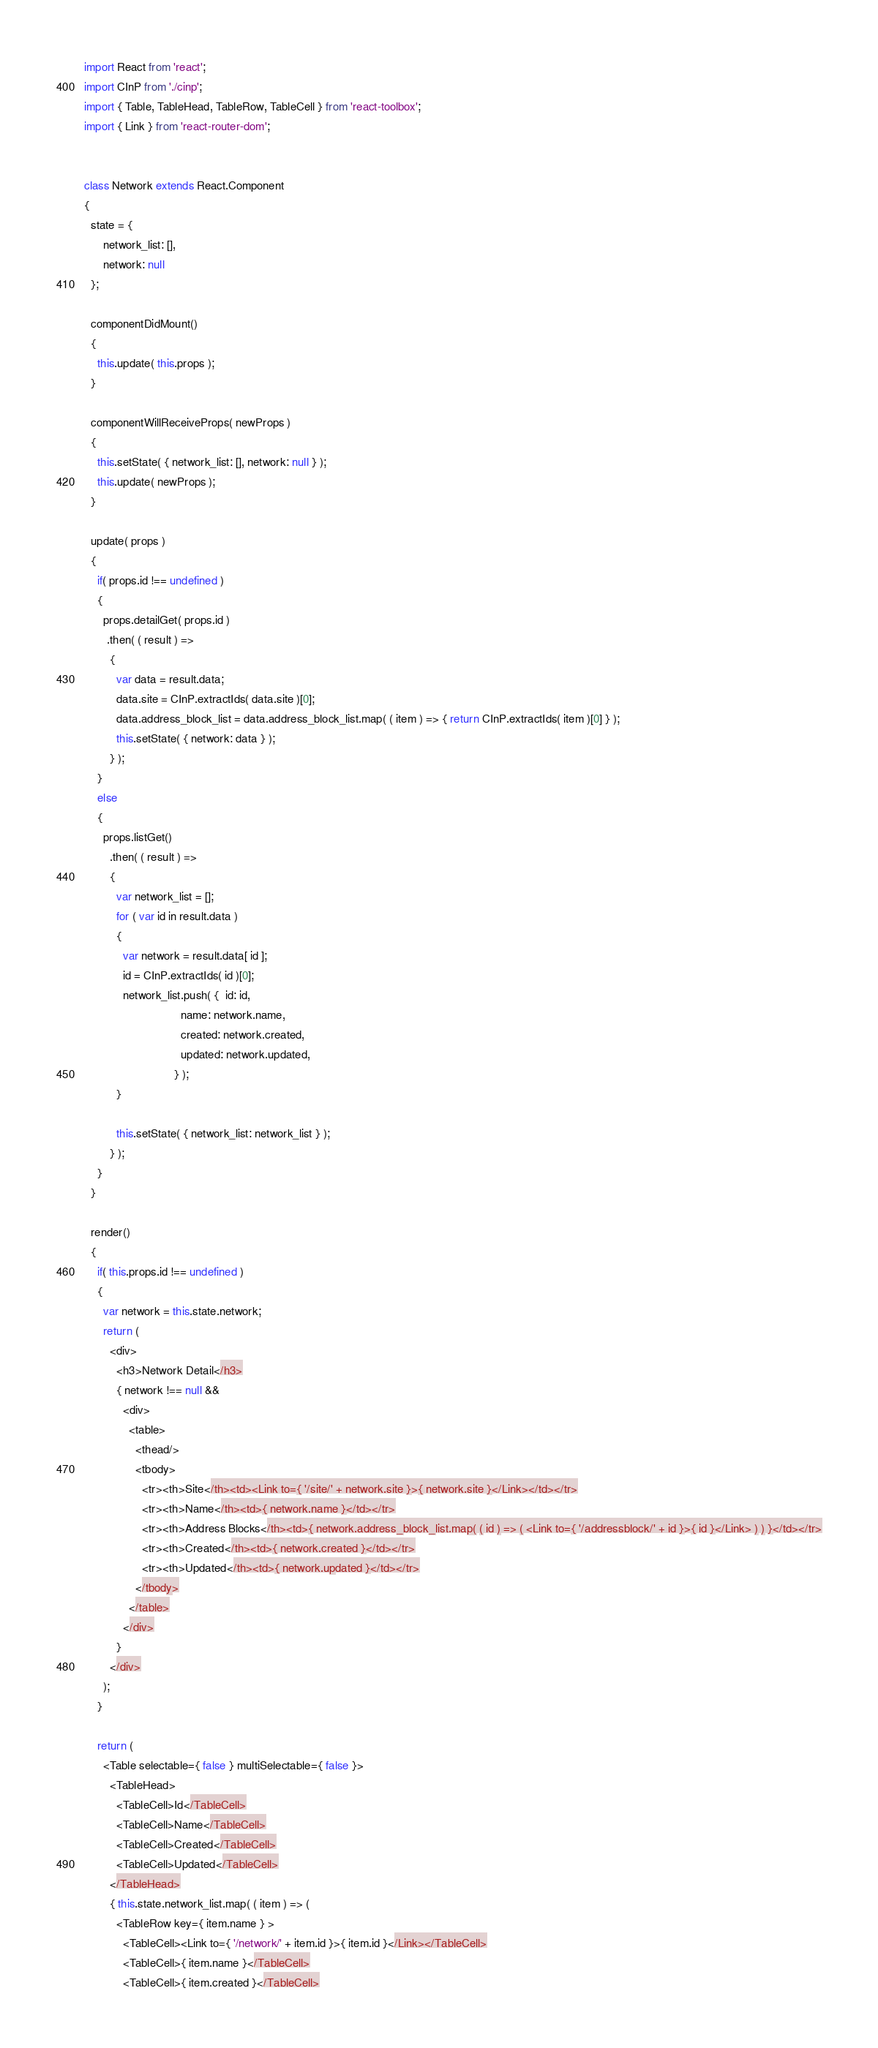<code> <loc_0><loc_0><loc_500><loc_500><_JavaScript_>import React from 'react';
import CInP from './cinp';
import { Table, TableHead, TableRow, TableCell } from 'react-toolbox';
import { Link } from 'react-router-dom';


class Network extends React.Component
{
  state = {
      network_list: [],
      network: null
  };

  componentDidMount()
  {
    this.update( this.props );
  }

  componentWillReceiveProps( newProps )
  {
    this.setState( { network_list: [], network: null } );
    this.update( newProps );
  }

  update( props )
  {
    if( props.id !== undefined )
    {
      props.detailGet( props.id )
       .then( ( result ) =>
        {
          var data = result.data;
          data.site = CInP.extractIds( data.site )[0];
          data.address_block_list = data.address_block_list.map( ( item ) => { return CInP.extractIds( item )[0] } );
          this.setState( { network: data } );
        } );
    }
    else
    {
      props.listGet()
        .then( ( result ) =>
        {
          var network_list = [];
          for ( var id in result.data )
          {
            var network = result.data[ id ];
            id = CInP.extractIds( id )[0];
            network_list.push( {  id: id,
                              name: network.name,
                              created: network.created,
                              updated: network.updated,
                            } );
          }

          this.setState( { network_list: network_list } );
        } );
    }
  }

  render()
  {
    if( this.props.id !== undefined )
    {
      var network = this.state.network;
      return (
        <div>
          <h3>Network Detail</h3>
          { network !== null &&
            <div>
              <table>
                <thead/>
                <tbody>
                  <tr><th>Site</th><td><Link to={ '/site/' + network.site }>{ network.site }</Link></td></tr>
                  <tr><th>Name</th><td>{ network.name }</td></tr>
                  <tr><th>Address Blocks</th><td>{ network.address_block_list.map( ( id ) => ( <Link to={ '/addressblock/' + id }>{ id }</Link> ) ) }</td></tr>
                  <tr><th>Created</th><td>{ network.created }</td></tr>
                  <tr><th>Updated</th><td>{ network.updated }</td></tr>
                </tbody>
              </table>
            </div>
          }
        </div>
      );
    }

    return (
      <Table selectable={ false } multiSelectable={ false }>
        <TableHead>
          <TableCell>Id</TableCell>
          <TableCell>Name</TableCell>
          <TableCell>Created</TableCell>
          <TableCell>Updated</TableCell>
        </TableHead>
        { this.state.network_list.map( ( item ) => (
          <TableRow key={ item.name } >
            <TableCell><Link to={ '/network/' + item.id }>{ item.id }</Link></TableCell>
            <TableCell>{ item.name }</TableCell>
            <TableCell>{ item.created }</TableCell></code> 